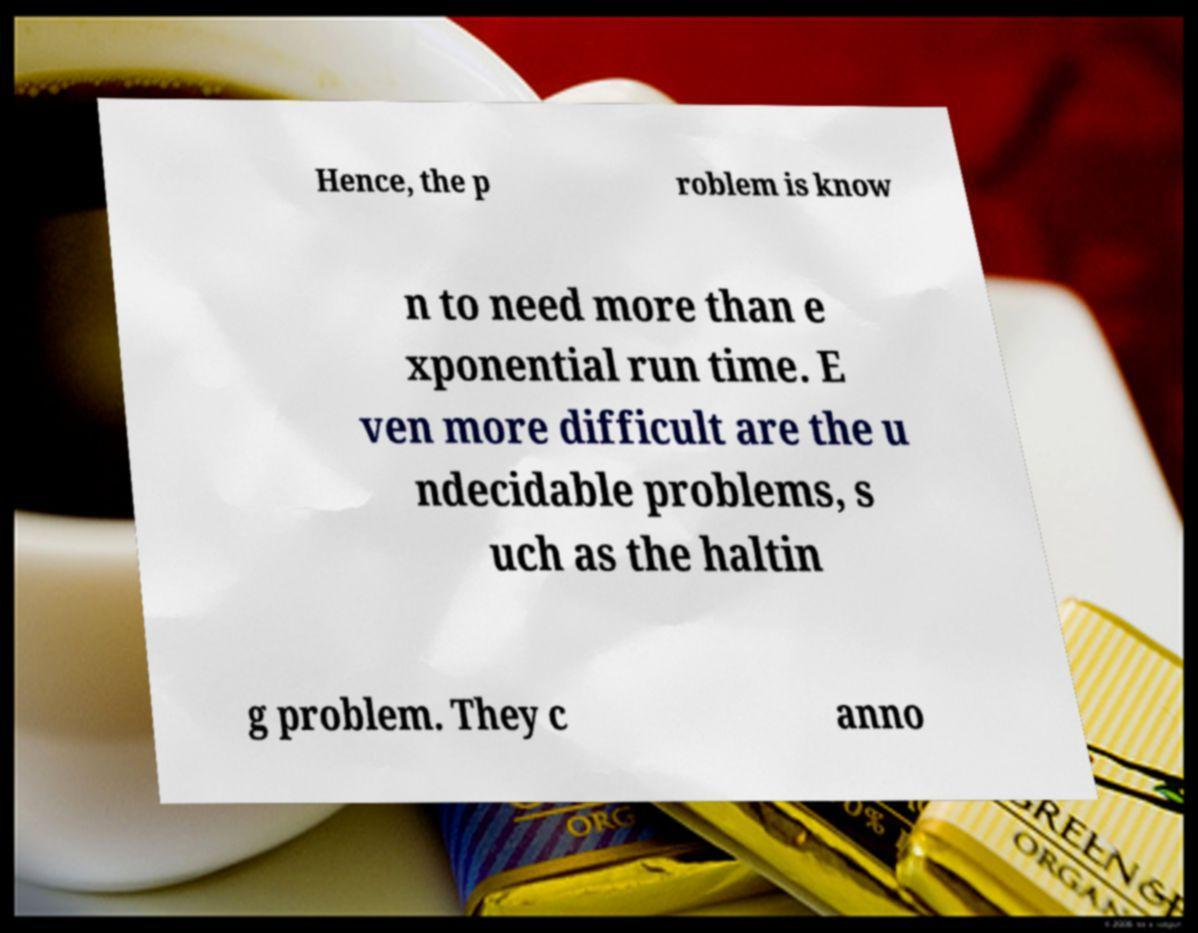For documentation purposes, I need the text within this image transcribed. Could you provide that? Hence, the p roblem is know n to need more than e xponential run time. E ven more difficult are the u ndecidable problems, s uch as the haltin g problem. They c anno 